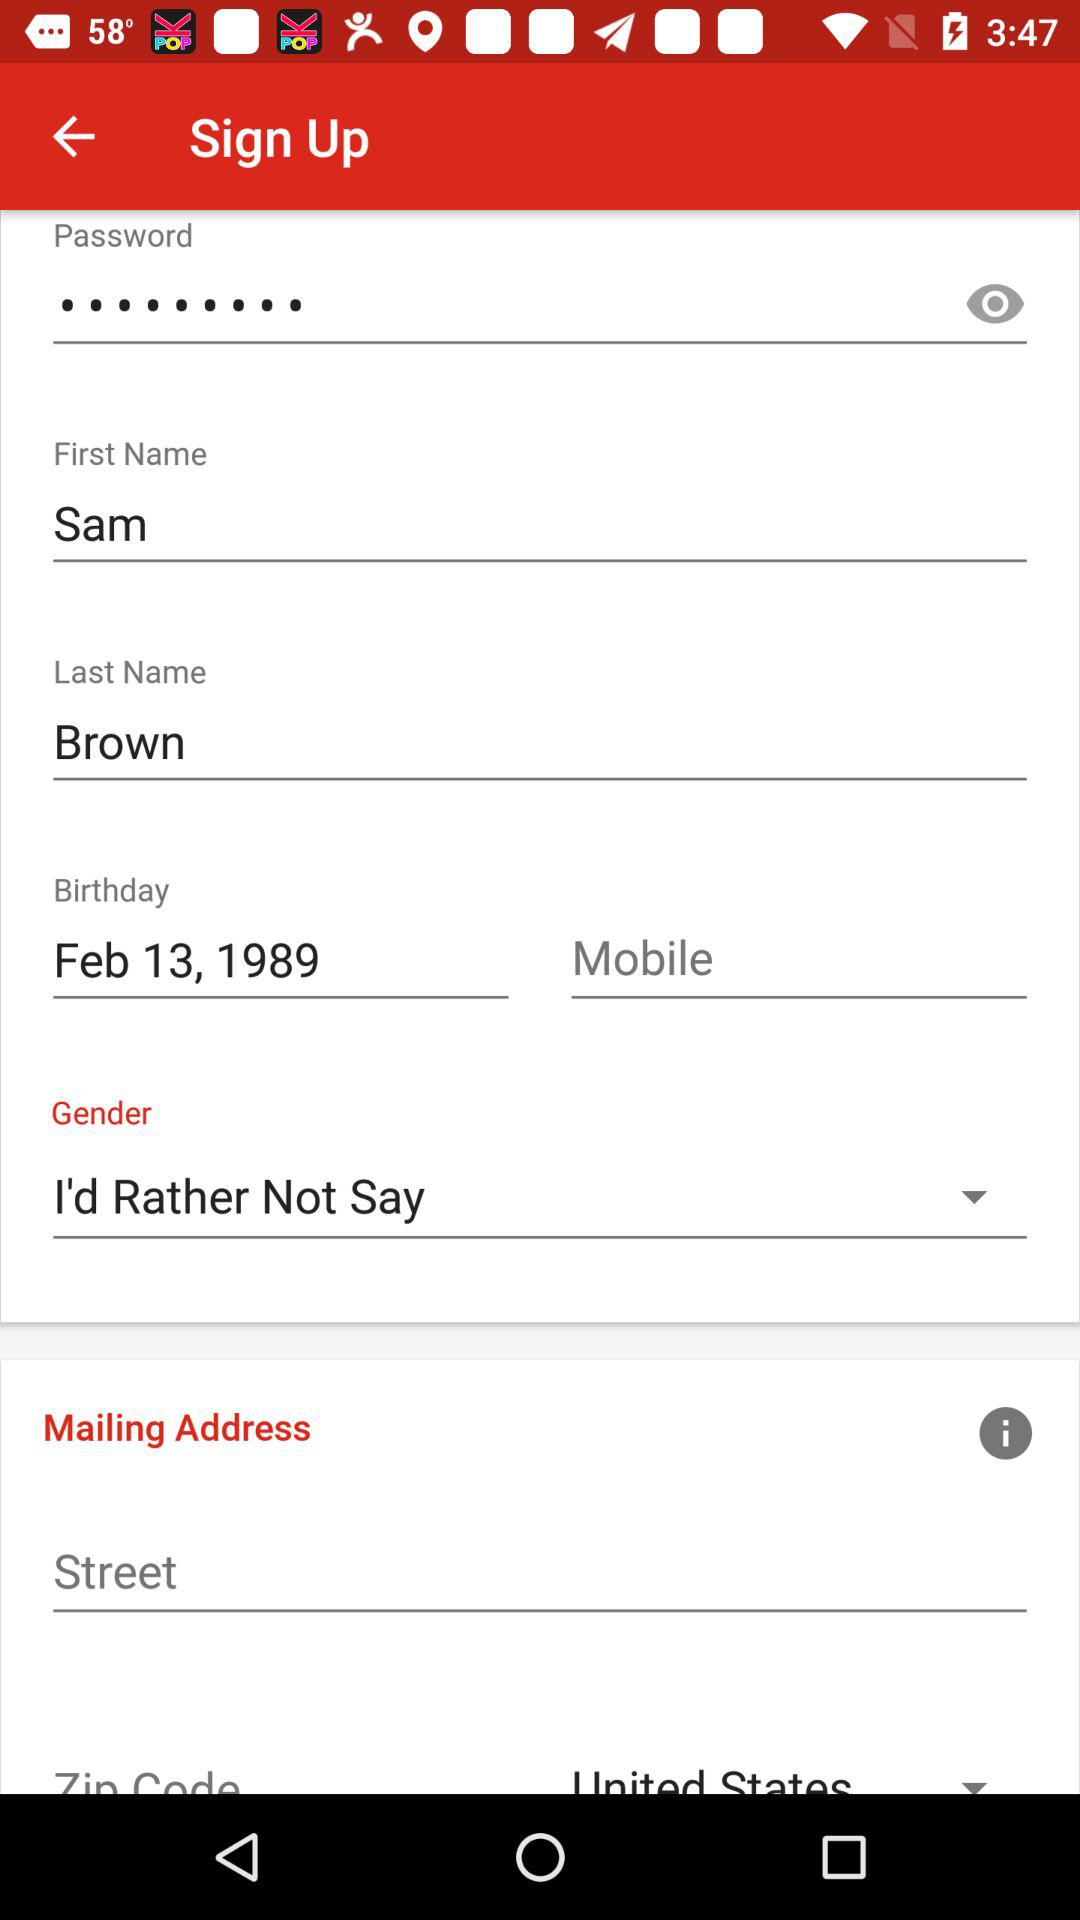What is the given last name? The given last name is Brown. 